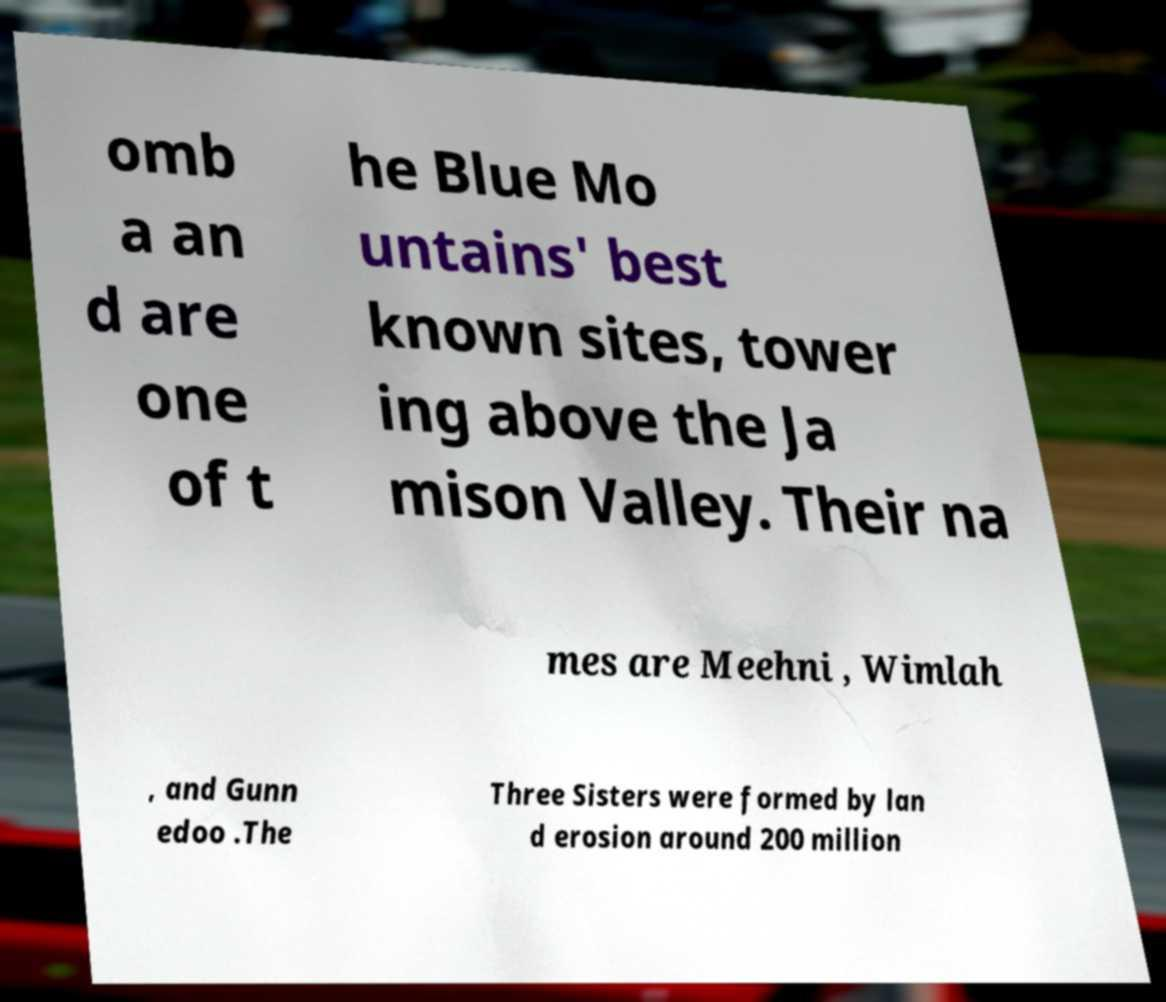There's text embedded in this image that I need extracted. Can you transcribe it verbatim? omb a an d are one of t he Blue Mo untains' best known sites, tower ing above the Ja mison Valley. Their na mes are Meehni , Wimlah , and Gunn edoo .The Three Sisters were formed by lan d erosion around 200 million 